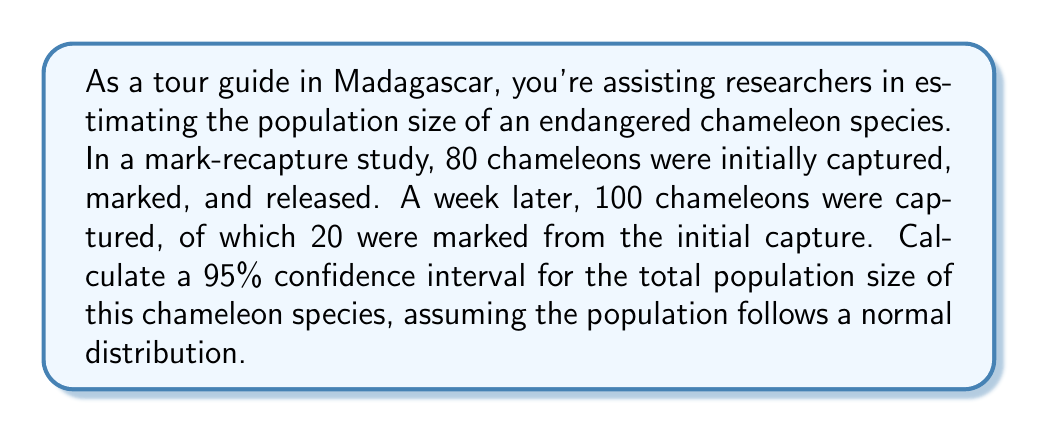Could you help me with this problem? Let's approach this step-by-step using the Lincoln-Petersen method and the normal approximation for the confidence interval:

1) First, we calculate the point estimate for the population size using the Lincoln-Petersen formula:

   $$\hat{N} = \frac{n_1 \cdot n_2}{m_2}$$

   Where:
   $n_1$ = number of animals marked on the first visit (80)
   $n_2$ = number of animals captured on the second visit (100)
   $m_2$ = number of marked animals recaptured on the second visit (20)

   $$\hat{N} = \frac{80 \cdot 100}{20} = 400$$

2) Next, we calculate the standard error of this estimate:

   $$SE(\hat{N}) = \sqrt{\frac{n_1^2 \cdot n_2 \cdot (n_2 - m_2)}{m_2^3}}$$

   $$SE(\hat{N}) = \sqrt{\frac{80^2 \cdot 100 \cdot (100 - 20)}{20^3}} \approx 69.28$$

3) For a 95% confidence interval, we use a z-score of 1.96. The formula for the confidence interval is:

   $$CI = \hat{N} \pm (z \cdot SE(\hat{N}))$$

4) Plugging in our values:

   $$CI = 400 \pm (1.96 \cdot 69.28)$$
   $$CI = 400 \pm 135.79$$

5) Therefore, our 95% confidence interval is:

   $$(400 - 135.79, 400 + 135.79) = (264.21, 535.79)$$

Rounding to the nearest whole number (as we're dealing with whole chameleons), our final confidence interval is (264, 536).
Answer: (264, 536) 